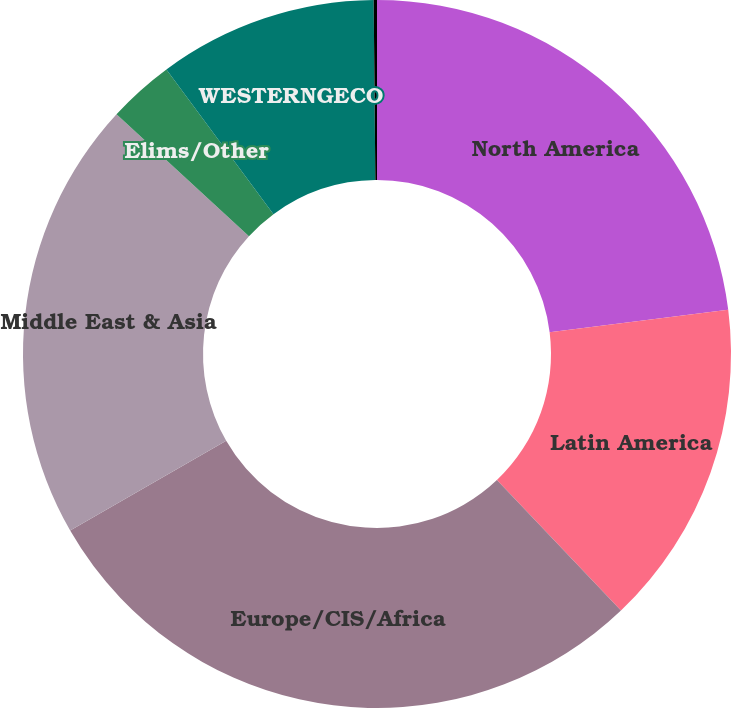<chart> <loc_0><loc_0><loc_500><loc_500><pie_chart><fcel>North America<fcel>Latin America<fcel>Europe/CIS/Africa<fcel>Middle East & Asia<fcel>Elims/Other<fcel>WESTERNGECO<fcel>Corporate (1)<nl><fcel>23.01%<fcel>14.89%<fcel>28.79%<fcel>20.15%<fcel>3.02%<fcel>9.99%<fcel>0.15%<nl></chart> 